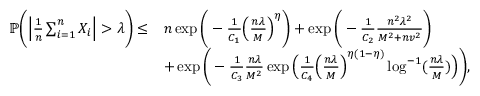<formula> <loc_0><loc_0><loc_500><loc_500>\begin{array} { r l } { \mathbb { P } \left ( \left | \frac { 1 } { n } \sum _ { i = 1 } ^ { n } X _ { i } \right | > \lambda \right ) \leq } & { n \exp \left ( - \frac { 1 } { C _ { 1 } } \left ( \frac { n \lambda } { M } \right ) ^ { \eta } \right ) + \exp \left ( - \frac { 1 } { C _ { 2 } } \frac { n ^ { 2 } \lambda ^ { 2 } } { M ^ { 2 } + n v ^ { 2 } } \right ) } \\ & { + \exp \left ( - \frac { 1 } { C _ { 3 } } \frac { n \lambda } { M ^ { 2 } } \exp \left ( \frac { 1 } { C _ { 4 } } \left ( \frac { n \lambda } { M } \right ) ^ { \eta ( 1 - \eta ) } \log ^ { - 1 } ( \frac { n \lambda } { M } ) \right ) \right ) , } \end{array}</formula> 